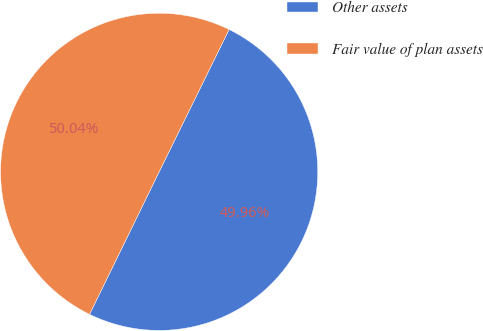Convert chart to OTSL. <chart><loc_0><loc_0><loc_500><loc_500><pie_chart><fcel>Other assets<fcel>Fair value of plan assets<nl><fcel>49.96%<fcel>50.04%<nl></chart> 